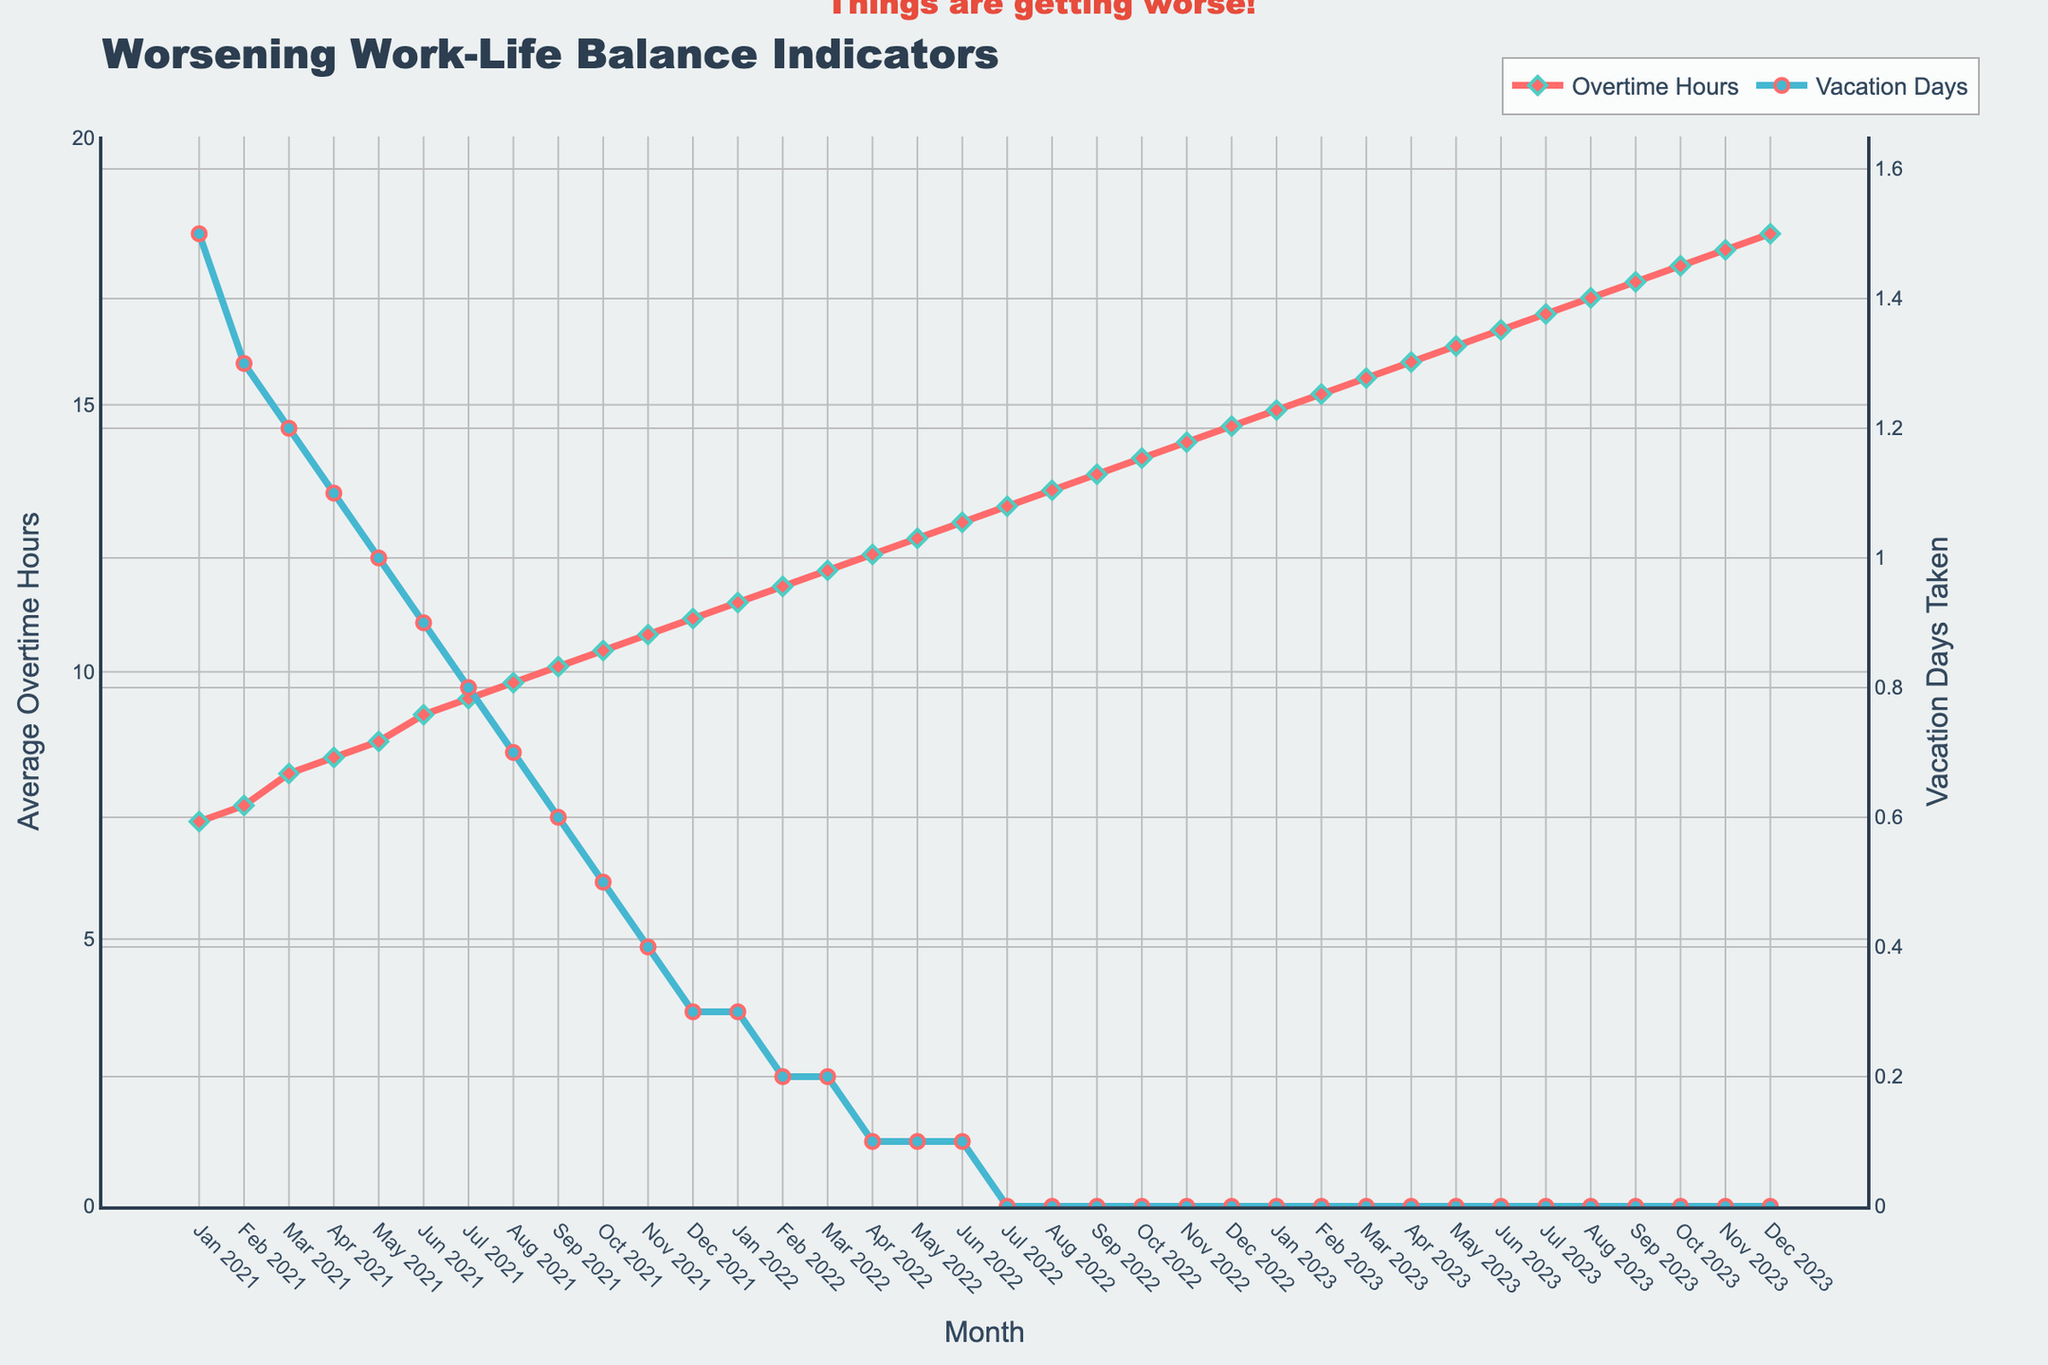Why do average overtime hours and vacation days taken appear to have an inverse relationship? Overtime hours are steadily increasing while vacation days taken are steadily decreasing over the same time period, suggesting that as employees are asked to work more overtime, they take fewer vacation days.
Answer: Inverse relationship What month showed the highest average overtime hours, and what was the value? According to the plot, December 2023 showed the highest average overtime hours, reaching 18.2 hours.
Answer: December 2023, 18.2 hours How many months have passed since the average overtime hours hit double digits (10 hours or more)? The average overtime hours reached 10 in September 2021. From September 2021 to December 2023, there are 28 months.
Answer: 28 months When did the vacation days taken drop to zero, and how long has it stayed at zero? Vacation days taken dropped to zero in July 2022 and have stayed at zero for 18 months up to December 2023.
Answer: July 2022, 18 months Which color represents vacation days taken, and what is its visual style? The color representing vacation days taken is blue, displayed as a line with circle markers.
Answer: Blue, line with circles Compare the trend in average overtime hours between January 2021 and December 2021. Average overtime hours showed a steady increase from 7.2 hours in January 2021 to 11.0 hours in December 2021.
Answer: Steady increase How did the average overtime hours change from Jan 2022 to Jan 2023? It increased from 11.3 hours in January 2022 to 14.9 hours in January 2023, which equals a 3.6-hour increase.
Answer: 3.6-hour increase Calculate the average of average overtime hours for the year 2021. The data for each month in 2021 sums up to 110.6. Dividing by 12 months, the average overtime hours for 2021 is 9.22 hours.
Answer: 9.22 hours What visual indication suggests that things are worsening with respect to work-life balance? The annotation "Things are getting worse!" above the graph clearly indicates this sentiment. Coupled with the increasing overtime hours and decreasing vacation days, it suggests a worsening balance.
Answer: Annotation and trends During which month in 2022 did the average overtime hours first surpass 12 hours, and what was the number of vacation days taken at that point? In April 2022, average overtime hours first surpassed 12 hours, when the number of vacation days taken was 0.1 days.
Answer: April 2022, 0.1 days 